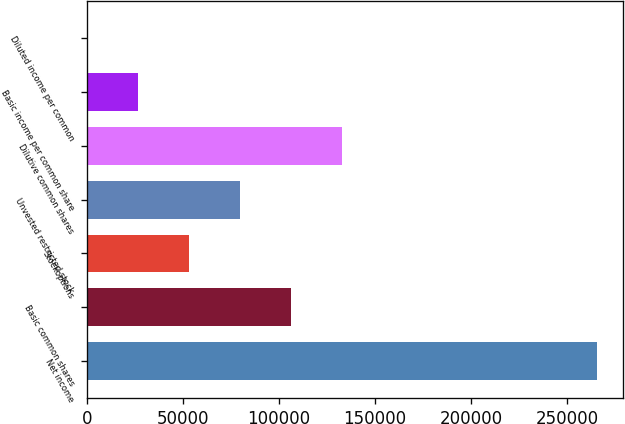Convert chart to OTSL. <chart><loc_0><loc_0><loc_500><loc_500><bar_chart><fcel>Net income<fcel>Basic common shares<fcel>Stockoptions<fcel>Unvested restricted stock<fcel>Dilutive common shares<fcel>Basic income per common share<fcel>Diluted income per common<nl><fcel>265895<fcel>106360<fcel>53181.1<fcel>79770.3<fcel>132949<fcel>26591.8<fcel>2.6<nl></chart> 